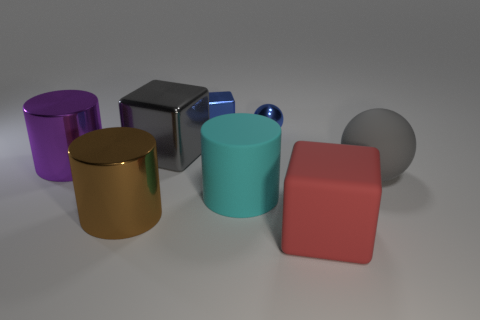Is there a small cylinder made of the same material as the large purple object?
Offer a very short reply. No. What is the material of the ball that is the same size as the red rubber cube?
Give a very brief answer. Rubber. Is the number of red rubber things to the left of the small blue block less than the number of big purple shiny objects that are right of the big cyan rubber cylinder?
Your answer should be very brief. No. What is the shape of the rubber object that is both in front of the big matte ball and behind the red cube?
Offer a very short reply. Cylinder. How many large gray matte objects are the same shape as the big red thing?
Offer a terse response. 0. There is a gray sphere that is made of the same material as the big cyan thing; what size is it?
Provide a short and direct response. Large. Are there more tiny green shiny spheres than small metal cubes?
Your answer should be very brief. No. What is the color of the big block behind the gray sphere?
Make the answer very short. Gray. There is a cube that is both in front of the blue shiny block and behind the big red rubber cube; how big is it?
Keep it short and to the point. Large. What number of cylinders are the same size as the brown metallic thing?
Ensure brevity in your answer.  2. 